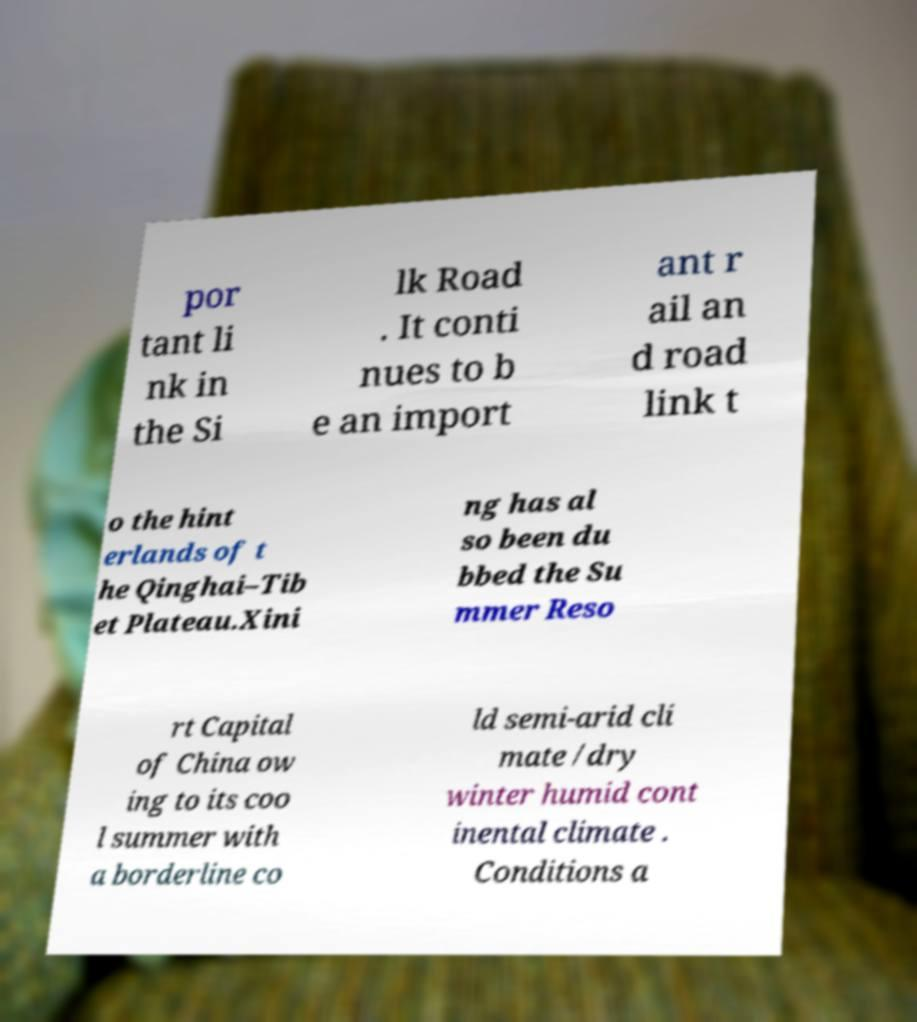Could you extract and type out the text from this image? por tant li nk in the Si lk Road . It conti nues to b e an import ant r ail an d road link t o the hint erlands of t he Qinghai–Tib et Plateau.Xini ng has al so been du bbed the Su mmer Reso rt Capital of China ow ing to its coo l summer with a borderline co ld semi-arid cli mate /dry winter humid cont inental climate . Conditions a 